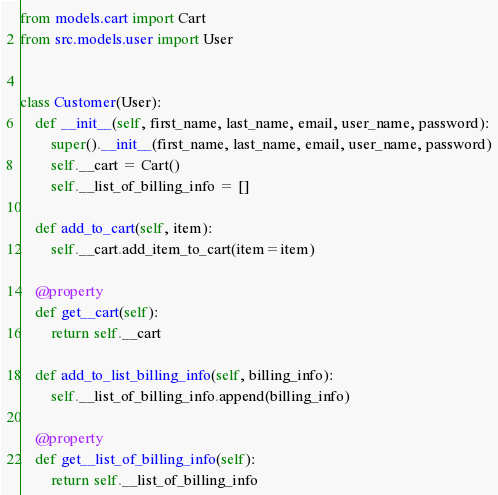Convert code to text. <code><loc_0><loc_0><loc_500><loc_500><_Python_>from models.cart import Cart
from src.models.user import User


class Customer(User):
    def __init__(self, first_name, last_name, email, user_name, password):
        super().__init__(first_name, last_name, email, user_name, password)
        self.__cart = Cart()
        self.__list_of_billing_info = []

    def add_to_cart(self, item):
        self.__cart.add_item_to_cart(item=item)

    @property
    def get__cart(self):
        return self.__cart

    def add_to_list_billing_info(self, billing_info):
        self.__list_of_billing_info.append(billing_info)

    @property
    def get__list_of_billing_info(self):
        return self.__list_of_billing_info</code> 